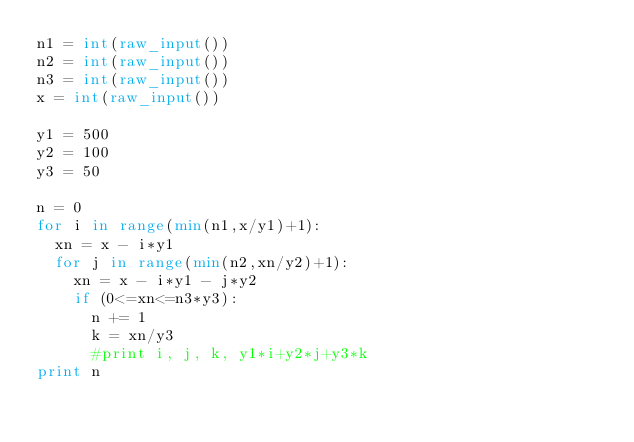Convert code to text. <code><loc_0><loc_0><loc_500><loc_500><_Python_>n1 = int(raw_input())
n2 = int(raw_input())
n3 = int(raw_input())
x = int(raw_input())

y1 = 500
y2 = 100
y3 = 50

n = 0
for i in range(min(n1,x/y1)+1):
  xn = x - i*y1
  for j in range(min(n2,xn/y2)+1):
    xn = x - i*y1 - j*y2
    if (0<=xn<=n3*y3):
      n += 1
      k = xn/y3
      #print i, j, k, y1*i+y2*j+y3*k
print n
</code> 